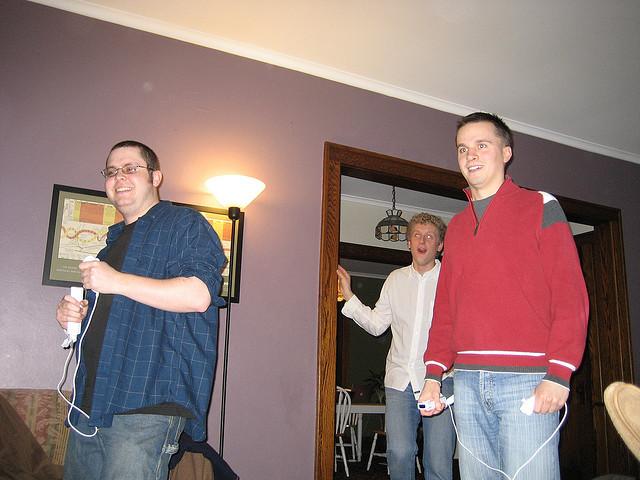What color is the shorter man's belt?
Give a very brief answer. Black. What color is the paint on the wall?
Short answer required. Purple. What tint of red is the man on the right wearing?
Concise answer only. Dark red. How many men are standing in this room?
Keep it brief. 3. Is everyone playing the game?
Short answer required. No. 